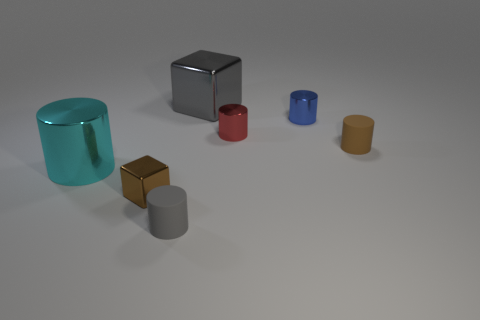Subtract all gray rubber cylinders. How many cylinders are left? 4 Subtract all red cylinders. How many cylinders are left? 4 Add 1 tiny brown objects. How many objects exist? 8 Subtract all cyan cylinders. Subtract all red cubes. How many cylinders are left? 4 Subtract all cubes. How many objects are left? 5 Add 1 tiny metallic objects. How many tiny metallic objects are left? 4 Add 3 tiny blue metallic cylinders. How many tiny blue metallic cylinders exist? 4 Subtract 0 purple cubes. How many objects are left? 7 Subtract all large blue metallic blocks. Subtract all large objects. How many objects are left? 5 